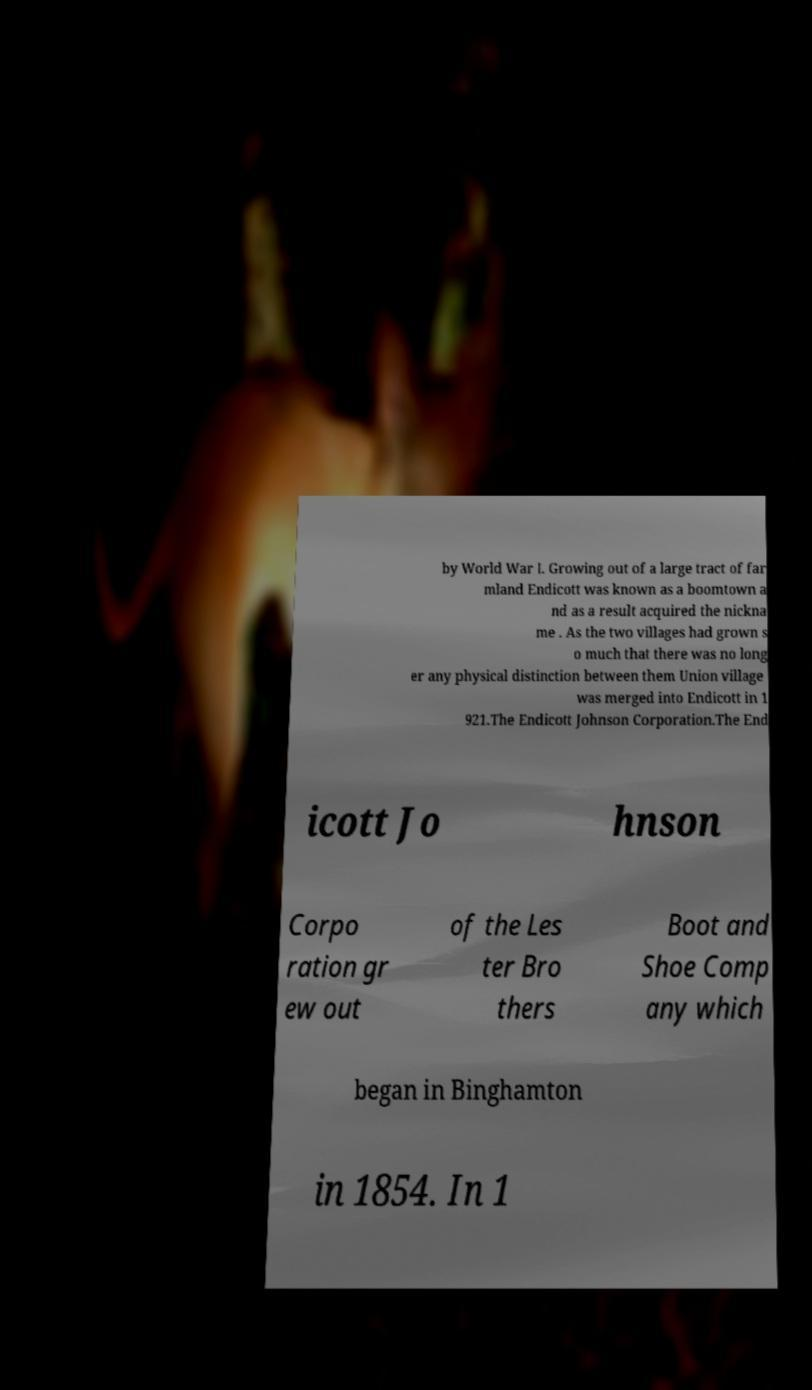There's text embedded in this image that I need extracted. Can you transcribe it verbatim? by World War I. Growing out of a large tract of far mland Endicott was known as a boomtown a nd as a result acquired the nickna me . As the two villages had grown s o much that there was no long er any physical distinction between them Union village was merged into Endicott in 1 921.The Endicott Johnson Corporation.The End icott Jo hnson Corpo ration gr ew out of the Les ter Bro thers Boot and Shoe Comp any which began in Binghamton in 1854. In 1 